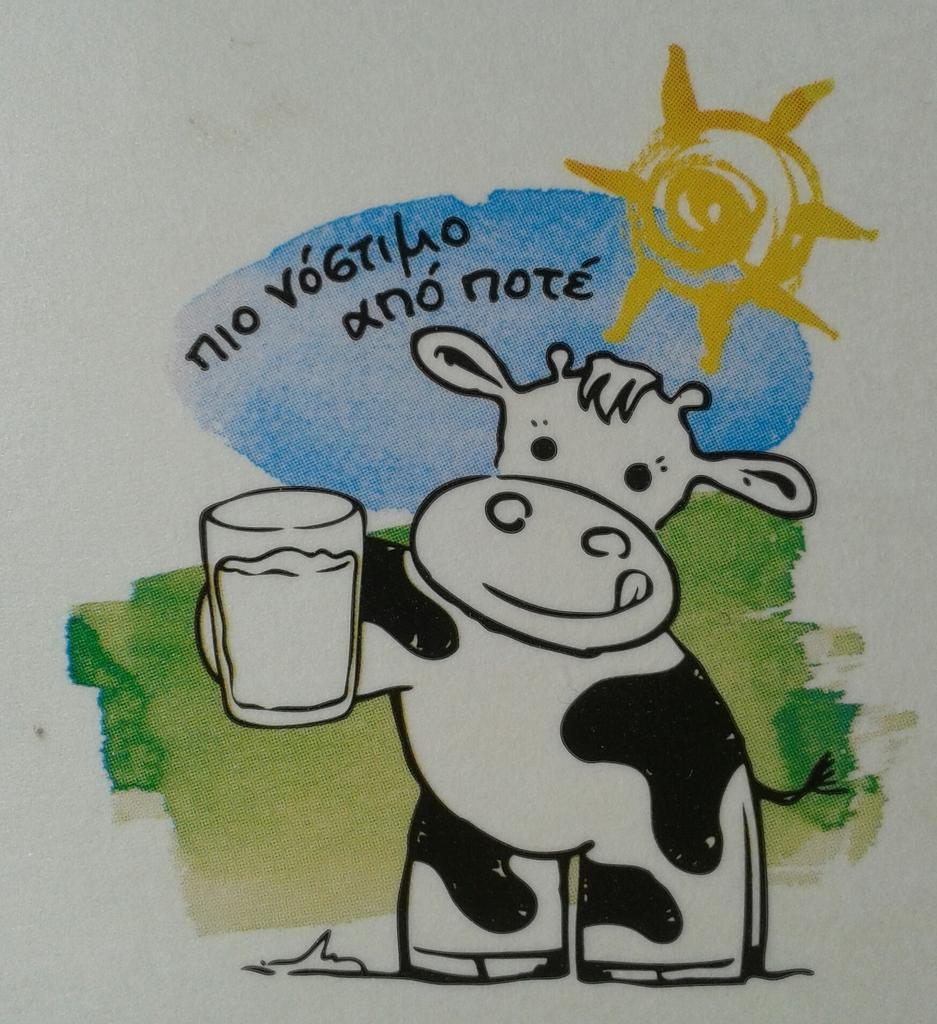What is the main subject of the image? There is a painting in the image. What is depicted in the painting? The painting contains a cartoon image of an animal. What is the animal holding in the image? The animal is holding a glass in the image. What is written or displayed at the top of the painting? There is text at the top of the painting. What additional image can be seen on the paper? There is a sun image on the paper. What type of frame is used to display the painting in the image? The provided facts do not mention a frame, so we cannot determine the type of frame used to display the painting in the image. Can you tell me the name of the artist's daughter who inspired the painting? The provided facts do not mention any artist or their daughter, so we cannot determine if the painting was inspired by an artist's daughter. 